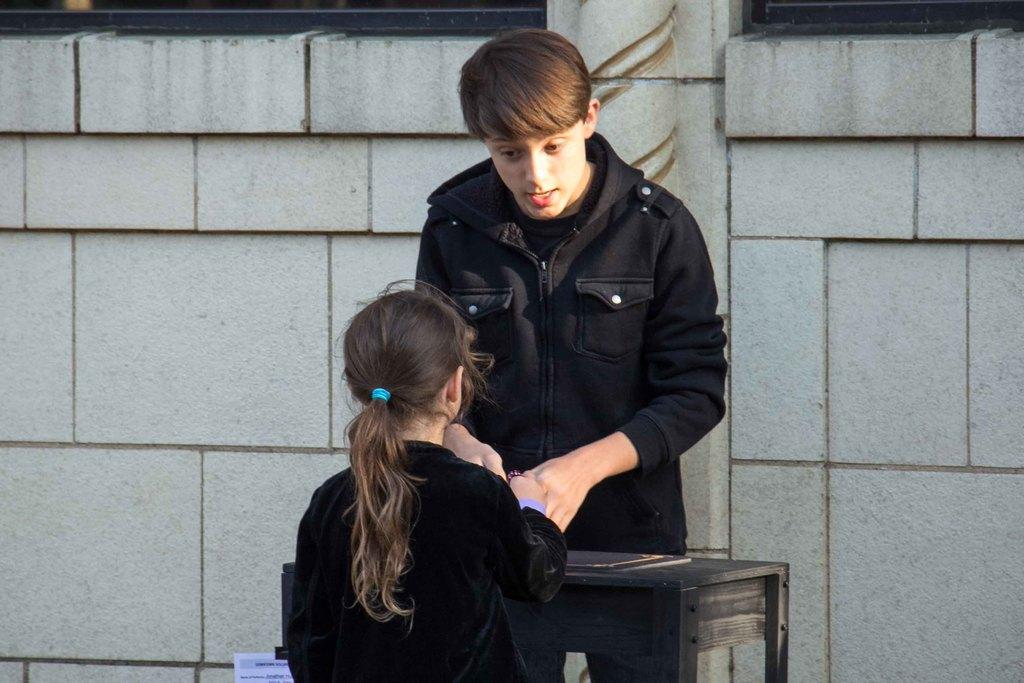Who is the main subject in the image? There is a boy in the image. What is the boy doing in the image? The boy is standing in front of a table and talking to a girl. Can you describe the girl's position in relation to the boy? The girl is in front of the boy. What can be seen in the background of the image? There is a wall visible in the background of the image. What type of pies are being served on the table in the image? There is no table or pies present in the image; it features a boy talking to a girl in front of a wall. 